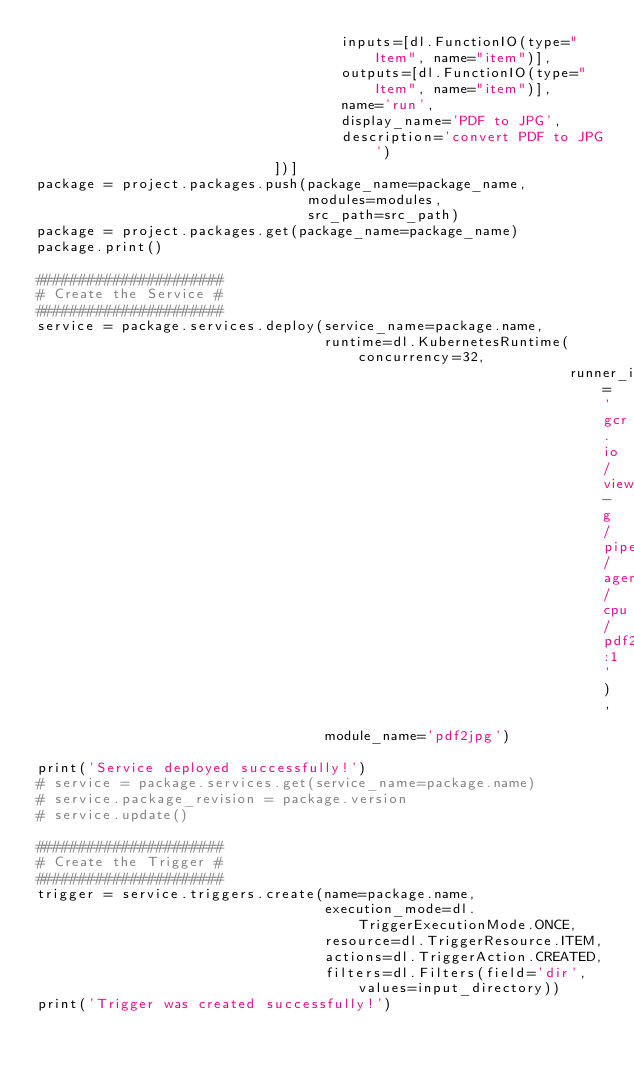Convert code to text. <code><loc_0><loc_0><loc_500><loc_500><_Python_>                                    inputs=[dl.FunctionIO(type="Item", name="item")],
                                    outputs=[dl.FunctionIO(type="Item", name="item")],
                                    name='run',
                                    display_name='PDF to JPG',
                                    description='convert PDF to JPG')
                            ])]
package = project.packages.push(package_name=package_name,
                                modules=modules,
                                src_path=src_path)
package = project.packages.get(package_name=package_name)
package.print()

######################
# Create the Service #
######################
service = package.services.deploy(service_name=package.name,
                                  runtime=dl.KubernetesRuntime(concurrency=32,
                                                               runner_image='gcr.io/viewo-g/piper/agent/cpu/pdf2jpg:1'),
                                  module_name='pdf2jpg')

print('Service deployed successfully!')
# service = package.services.get(service_name=package.name)
# service.package_revision = package.version
# service.update()

######################
# Create the Trigger #
######################
trigger = service.triggers.create(name=package.name,
                                  execution_mode=dl.TriggerExecutionMode.ONCE,
                                  resource=dl.TriggerResource.ITEM,
                                  actions=dl.TriggerAction.CREATED,
                                  filters=dl.Filters(field='dir', values=input_directory))
print('Trigger was created successfully!')
</code> 